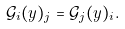Convert formula to latex. <formula><loc_0><loc_0><loc_500><loc_500>\mathcal { G } _ { i } ( y ) _ { j } = \mathcal { G } _ { j } ( y ) _ { i } .</formula> 